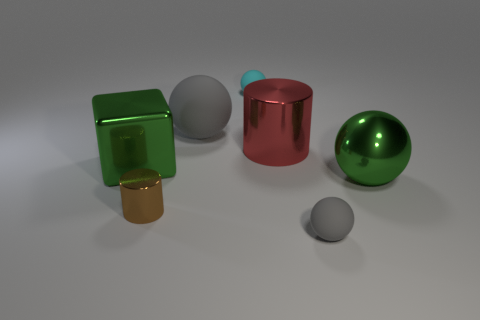There is a green metallic object that is the same shape as the big gray object; what size is it?
Give a very brief answer. Large. There is a big rubber object that is the same shape as the tiny cyan rubber thing; what color is it?
Offer a very short reply. Gray. How many small cylinders are the same material as the tiny cyan sphere?
Offer a terse response. 0. How many things are either large red cylinders or big matte balls to the right of the tiny metal object?
Keep it short and to the point. 2. Does the gray thing that is in front of the big green metal cube have the same material as the tiny cyan sphere?
Offer a very short reply. Yes. There is a block that is the same size as the red cylinder; what is its color?
Your answer should be very brief. Green. Is there another large red thing of the same shape as the large red thing?
Offer a terse response. No. There is a small object behind the red shiny object right of the small matte object to the left of the large red thing; what is its color?
Offer a terse response. Cyan. What number of matte objects are tiny cylinders or large red things?
Keep it short and to the point. 0. Is the number of gray objects right of the small cylinder greater than the number of small cyan matte objects to the right of the large red metal cylinder?
Your answer should be very brief. Yes. 